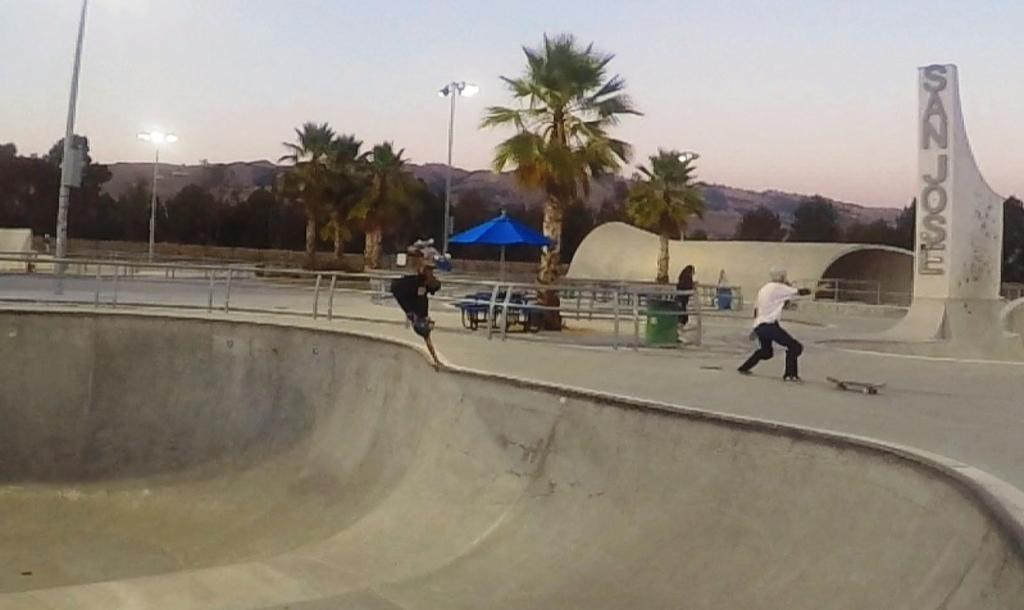What type of structure can be seen in the image? There is a shed in the image. What object is present for protection from the rain? There is an umbrella in the image. What type of natural vegetation is visible in the image? There are trees in the image. What are the poles used for in the image? The poles are likely used for supporting structures or utilities in the image. What type of illumination is present in the image? There are lights in the image. What type of geographical feature can be seen in the distance? There are mountains in the image. What type of barrier is present in the image? There are railings in the image. What type of artistic representation is present in the image? There is a statue in the image. Can you describe the person in the image? There is a person on the road in the image. What type of lace is draped over the statue in the image? There is no lace present in the image; the statue is not draped with any fabric. What type of curtain can be seen hanging from the shed in the image? There is no curtain present in the image; the shed does not have any curtains. 